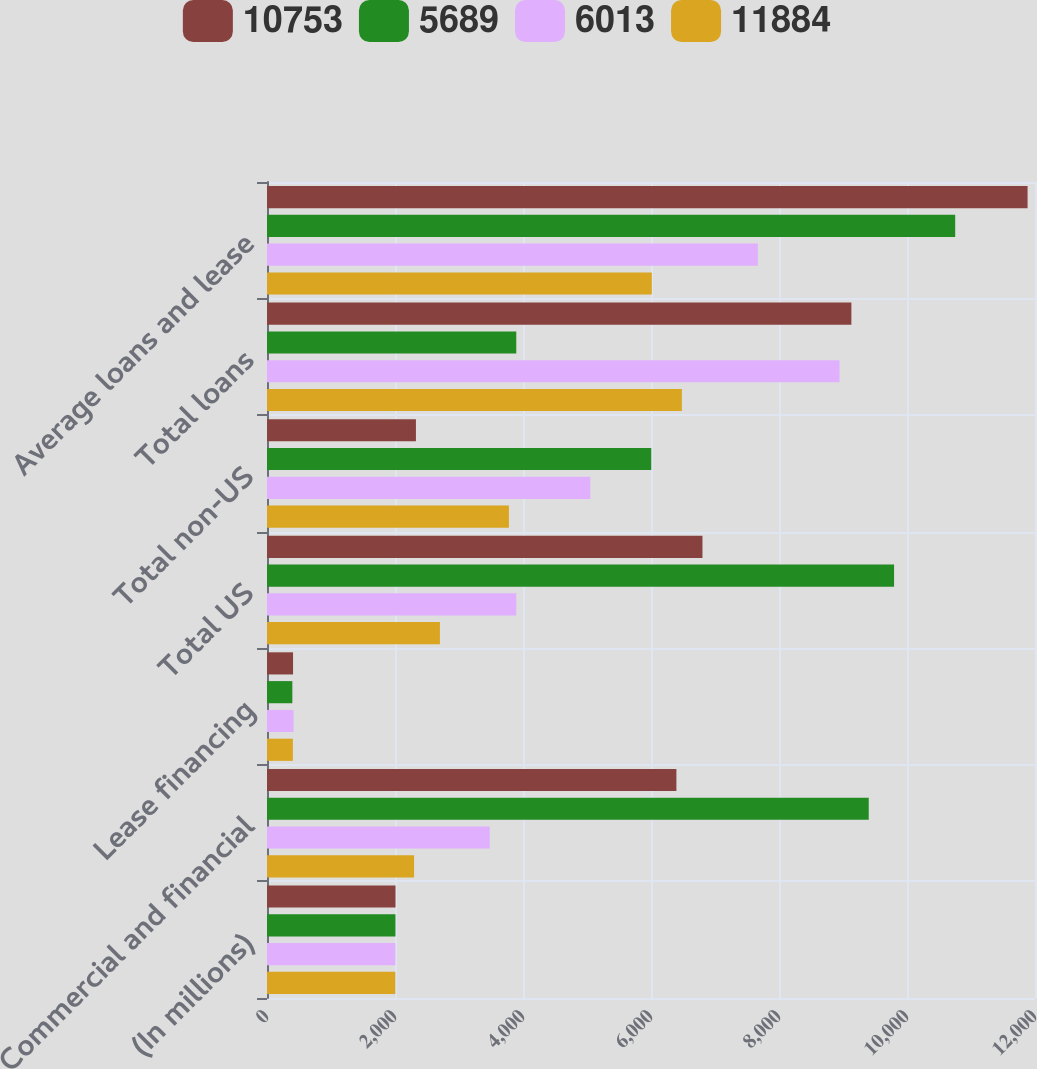Convert chart. <chart><loc_0><loc_0><loc_500><loc_500><stacked_bar_chart><ecel><fcel>(In millions)<fcel>Commercial and financial<fcel>Lease financing<fcel>Total US<fcel>Total non-US<fcel>Total loans<fcel>Average loans and lease<nl><fcel>10753<fcel>2008<fcel>6397<fcel>407<fcel>6804<fcel>2327<fcel>9131<fcel>11884<nl><fcel>5689<fcel>2007<fcel>9402<fcel>396<fcel>9798<fcel>6004<fcel>3895<fcel>10753<nl><fcel>6013<fcel>2006<fcel>3480<fcel>415<fcel>3895<fcel>5051<fcel>8946<fcel>7670<nl><fcel>11884<fcel>2005<fcel>2298<fcel>404<fcel>2702<fcel>3780<fcel>6482<fcel>6013<nl></chart> 